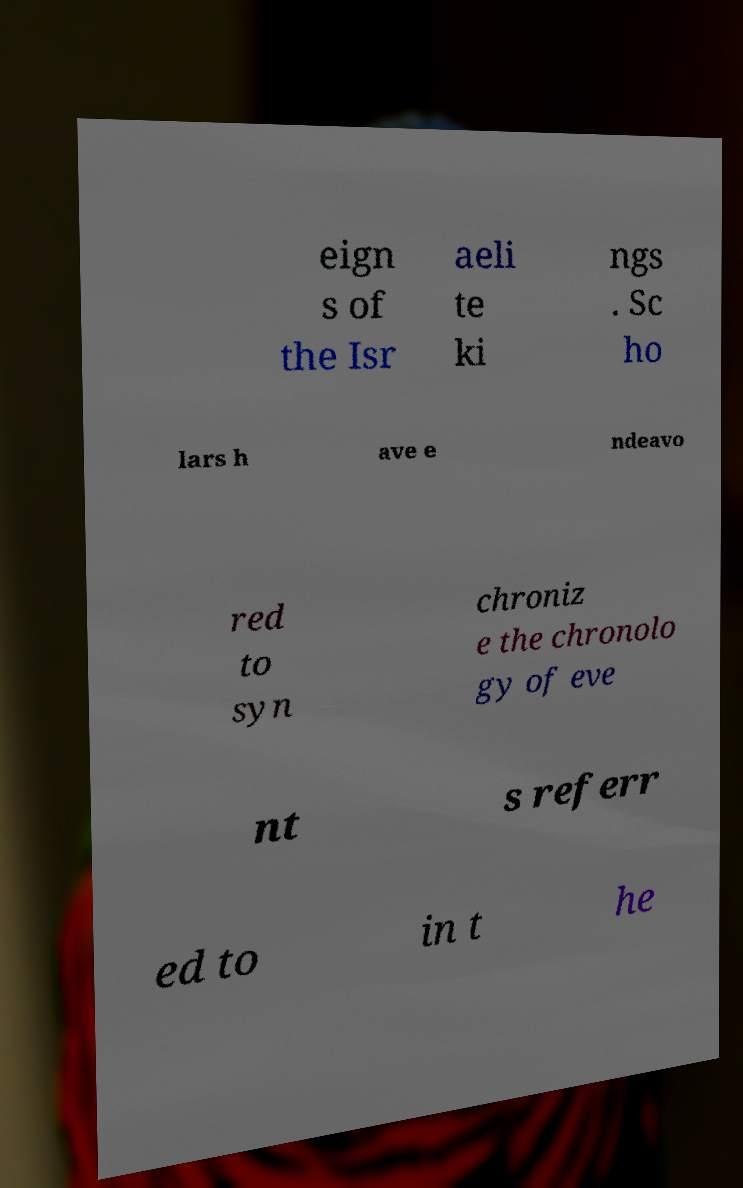For documentation purposes, I need the text within this image transcribed. Could you provide that? eign s of the Isr aeli te ki ngs . Sc ho lars h ave e ndeavo red to syn chroniz e the chronolo gy of eve nt s referr ed to in t he 